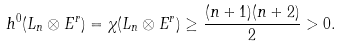Convert formula to latex. <formula><loc_0><loc_0><loc_500><loc_500>h ^ { 0 } ( L _ { n } \otimes E ^ { r } ) = \chi ( L _ { n } \otimes E ^ { r } ) \geq \frac { ( n + 1 ) ( n + 2 ) } { 2 } > 0 .</formula> 